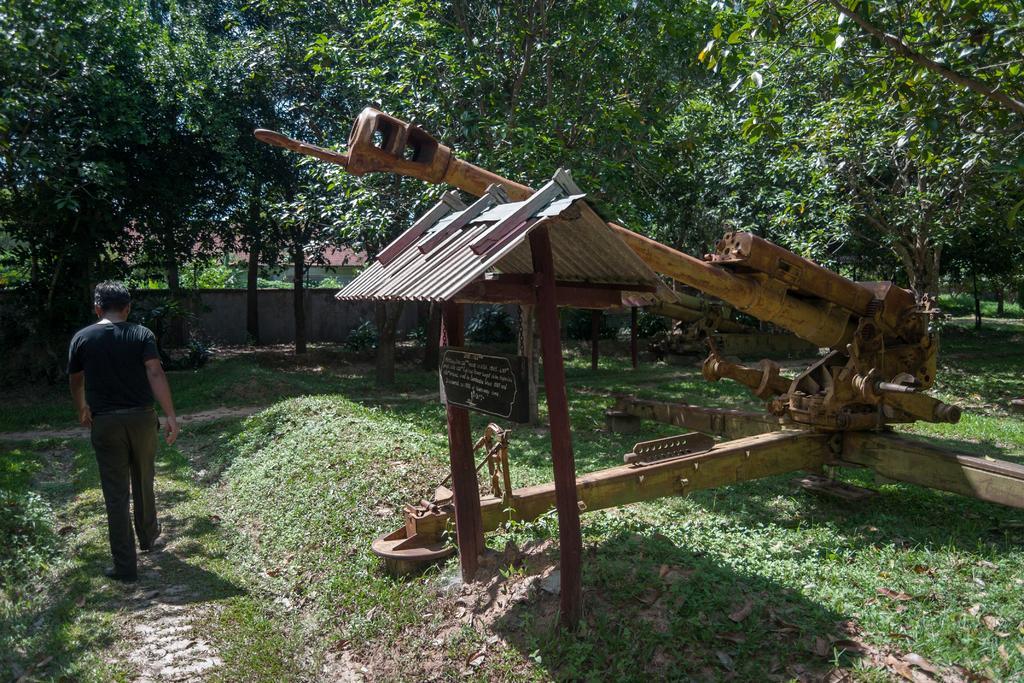Please provide a concise description of this image. In the image there is a person walking on the left side, on the right side there is wooden block with a machine above it on the grassland and behind there are trees all over the image. 